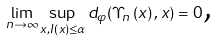<formula> <loc_0><loc_0><loc_500><loc_500>\lim _ { n \rightarrow \infty } \sup _ { x , I ( x ) \leq \alpha } d _ { \varphi } ( \Upsilon _ { n } \left ( x \right ) , x ) = 0 \text {,}</formula> 